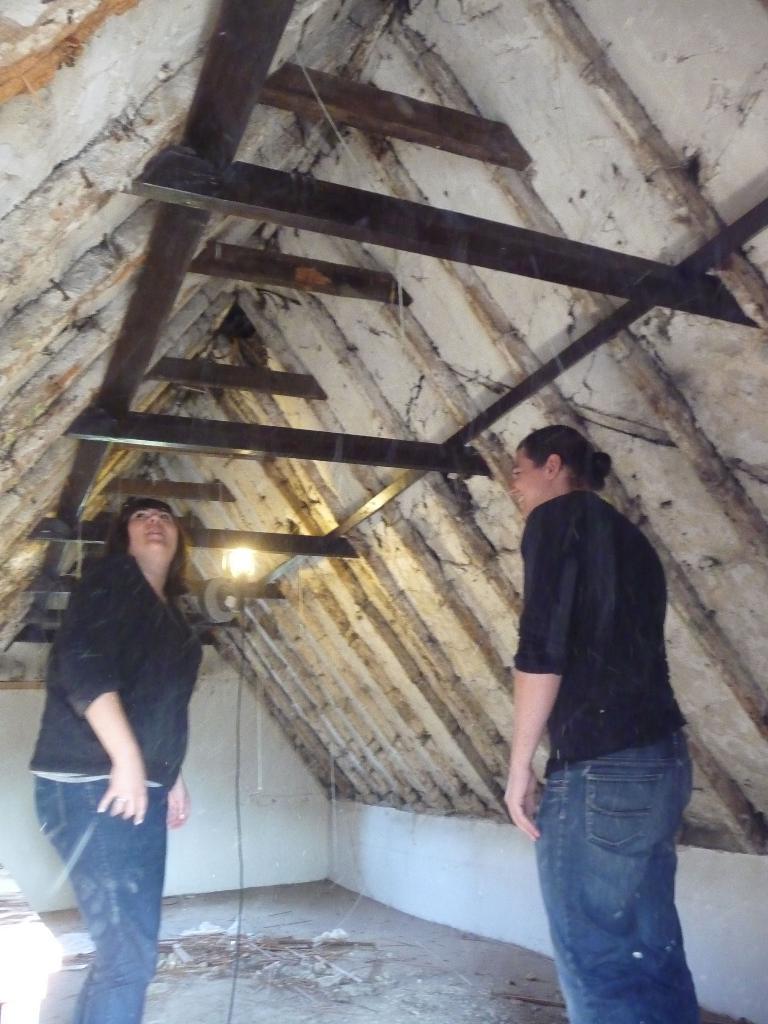Describe this image in one or two sentences. In the image two persons are standing. Behind them there is a roof and light. 